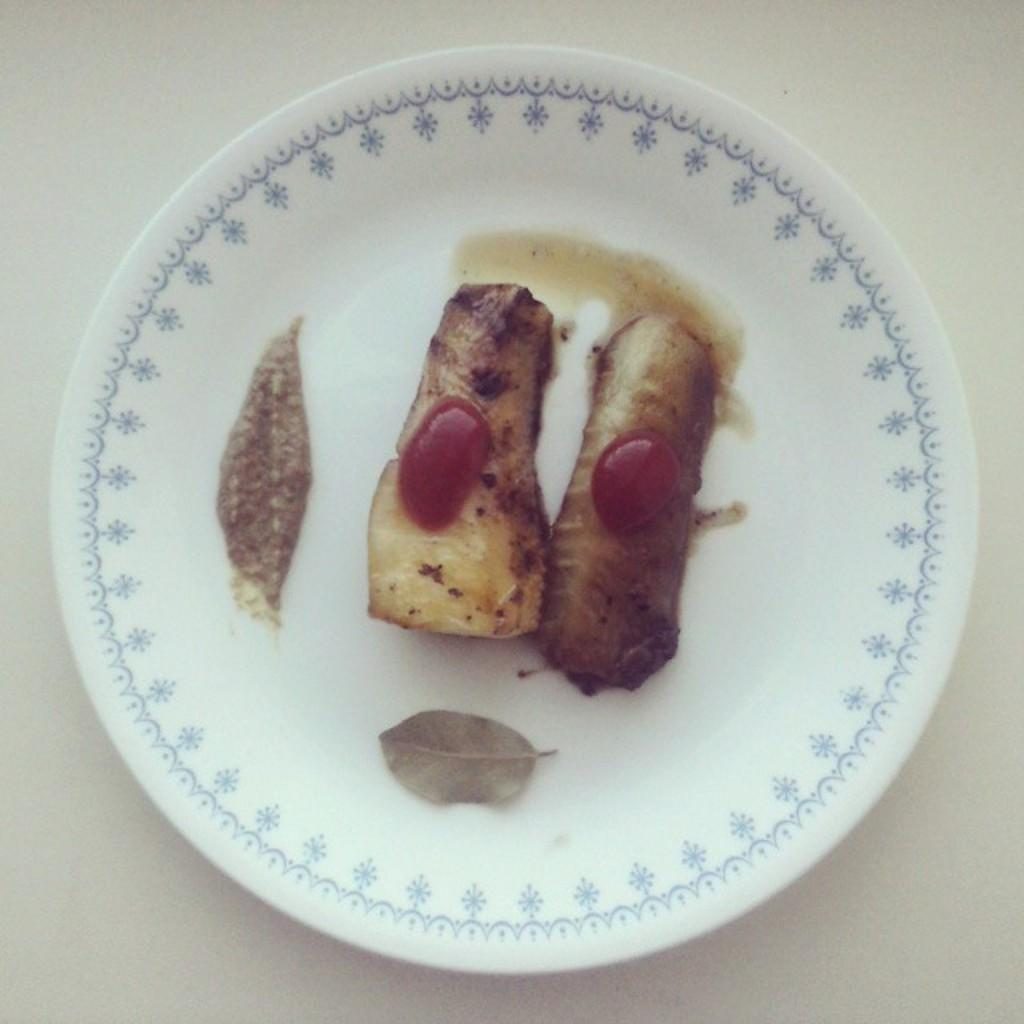What is on the plate in the image? There is food in a plate in the image. What condiment is present in the image? Ketchup is present in the image. What part of the room or setting can be seen at the bottom of the image? There is a floor visible at the bottom of the image. What type of cast can be seen on the person's arm in the image? There is no person or cast present in the image; it only features a plate of food and ketchup. 